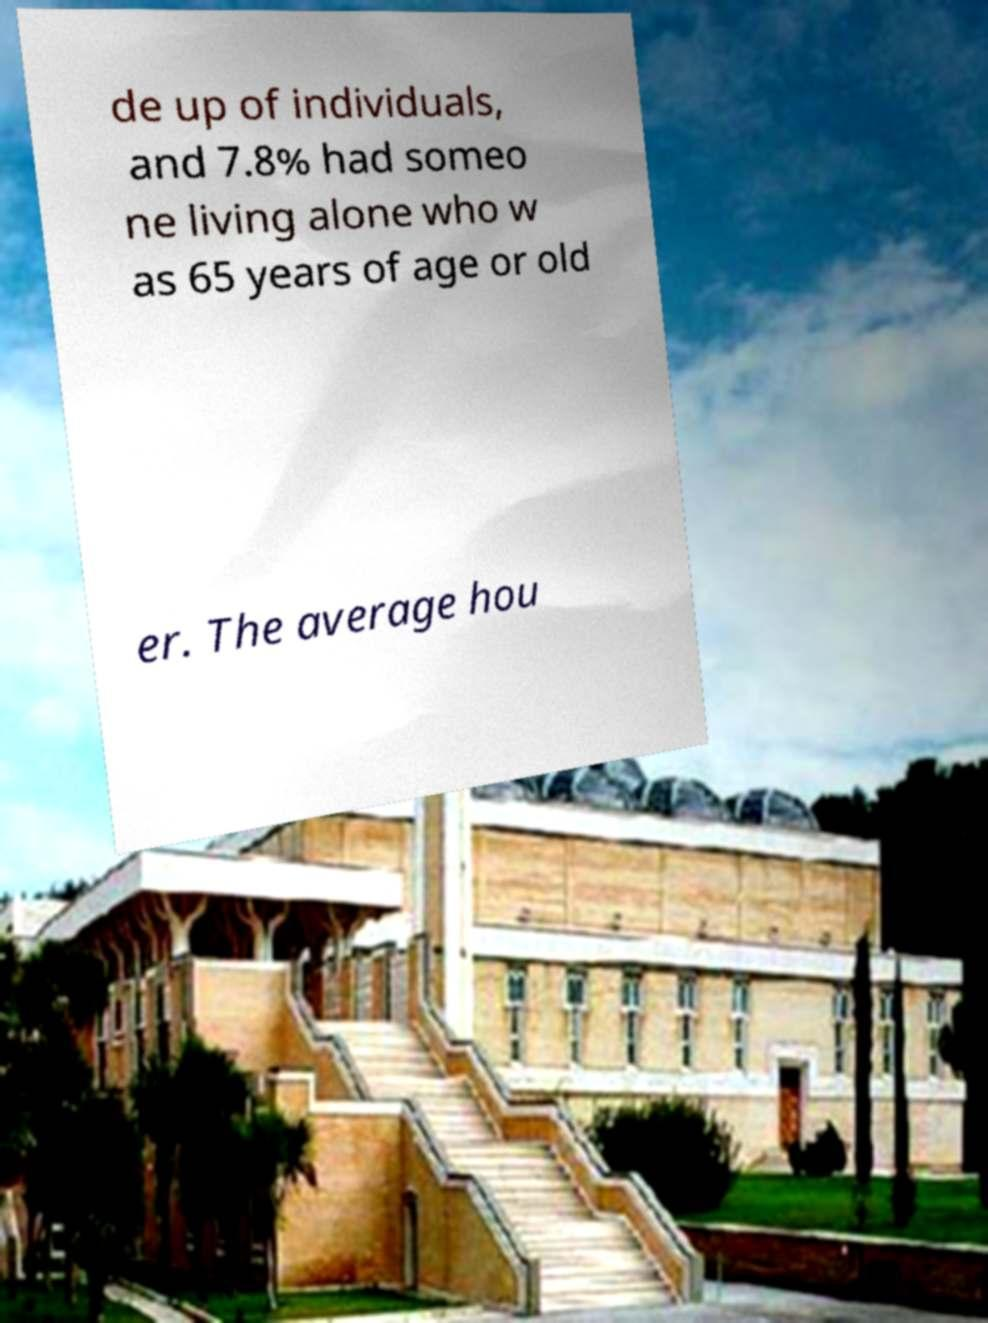Please read and relay the text visible in this image. What does it say? de up of individuals, and 7.8% had someo ne living alone who w as 65 years of age or old er. The average hou 